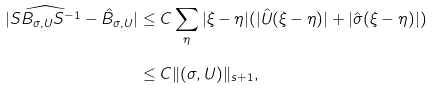<formula> <loc_0><loc_0><loc_500><loc_500>| \widehat { S B _ { \sigma , U } S ^ { - 1 } } - \hat { B } _ { \sigma , U } | & \leq C \sum _ { \eta } | \xi - \eta | ( | \hat { U } ( \xi - \eta ) | + | \hat { \sigma } ( \xi - \eta ) | ) \\ & \leq C \| ( \sigma , U ) \| _ { s + 1 } ,</formula> 